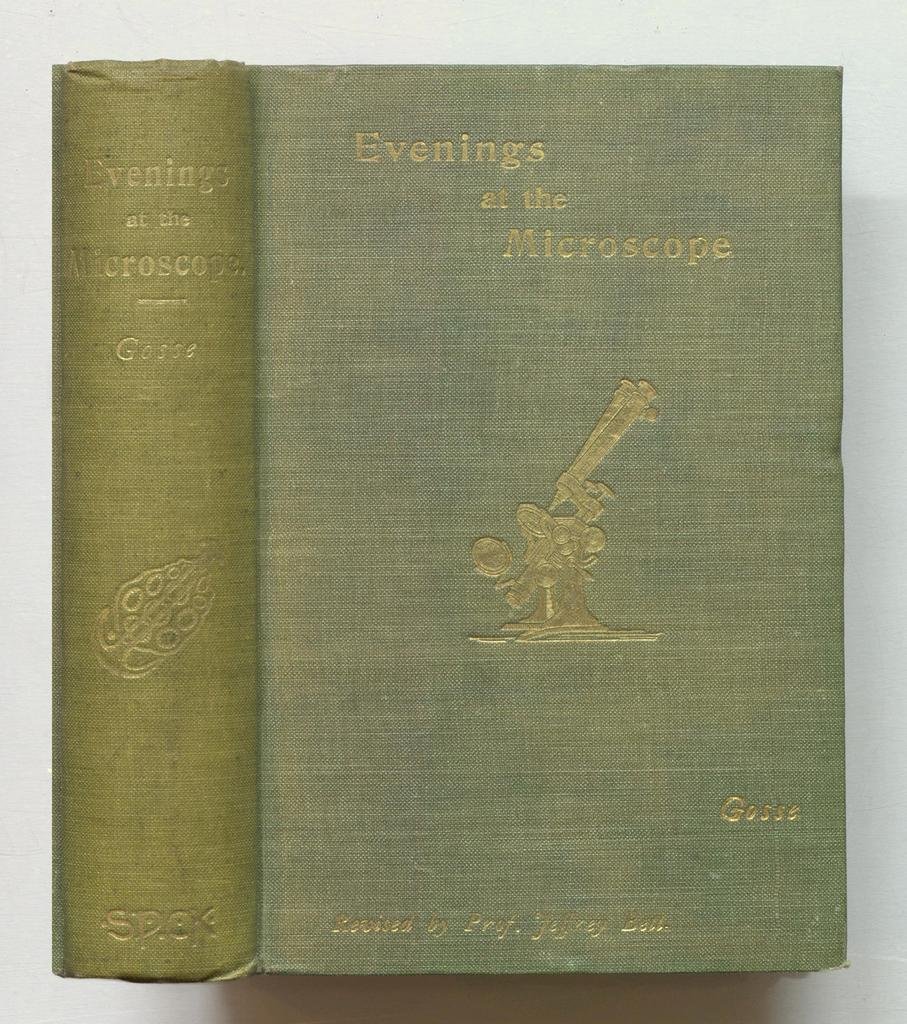<image>
Summarize the visual content of the image. A book has a turquoise cover and is titled Evenings at the Microscope. 